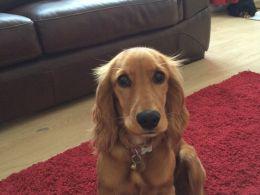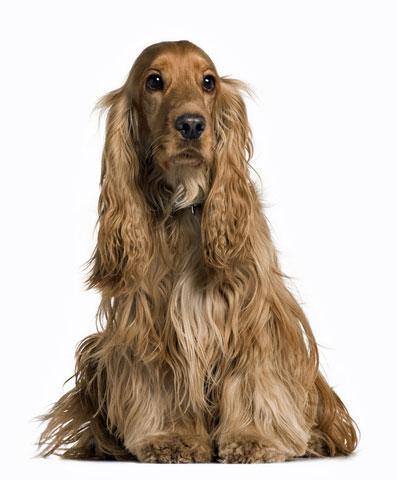The first image is the image on the left, the second image is the image on the right. Given the left and right images, does the statement "One dog is laying on a tile floor." hold true? Answer yes or no. No. The first image is the image on the left, the second image is the image on the right. Given the left and right images, does the statement "a dog is in front of furniture on a wood floor" hold true? Answer yes or no. Yes. 